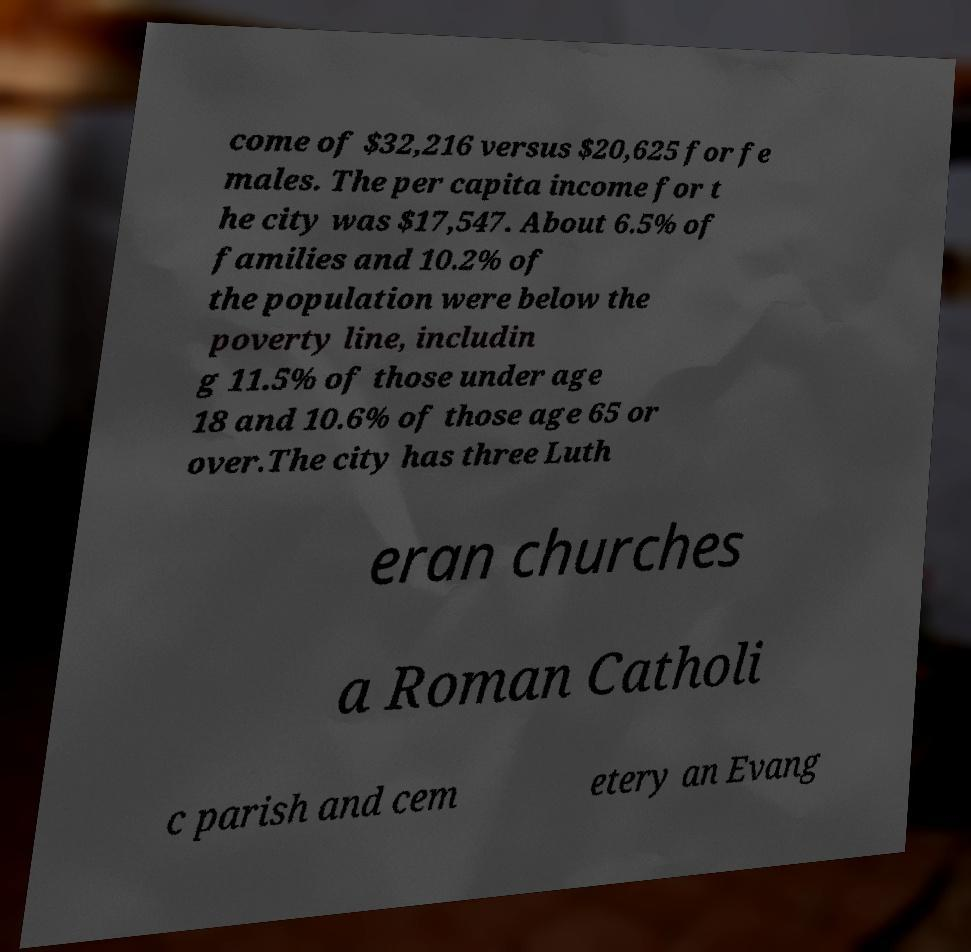Please identify and transcribe the text found in this image. come of $32,216 versus $20,625 for fe males. The per capita income for t he city was $17,547. About 6.5% of families and 10.2% of the population were below the poverty line, includin g 11.5% of those under age 18 and 10.6% of those age 65 or over.The city has three Luth eran churches a Roman Catholi c parish and cem etery an Evang 